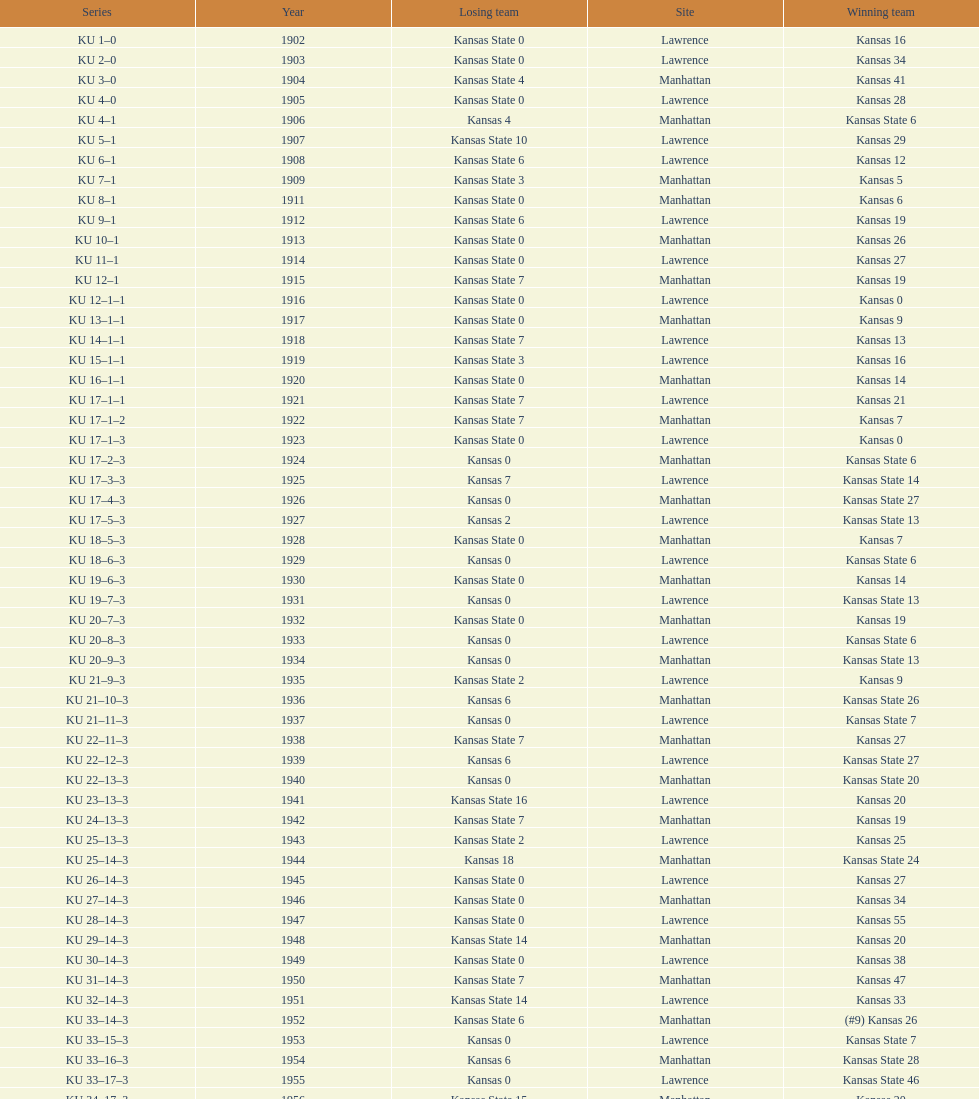Who had the most wins in the 1950's: kansas or kansas state? Kansas. 